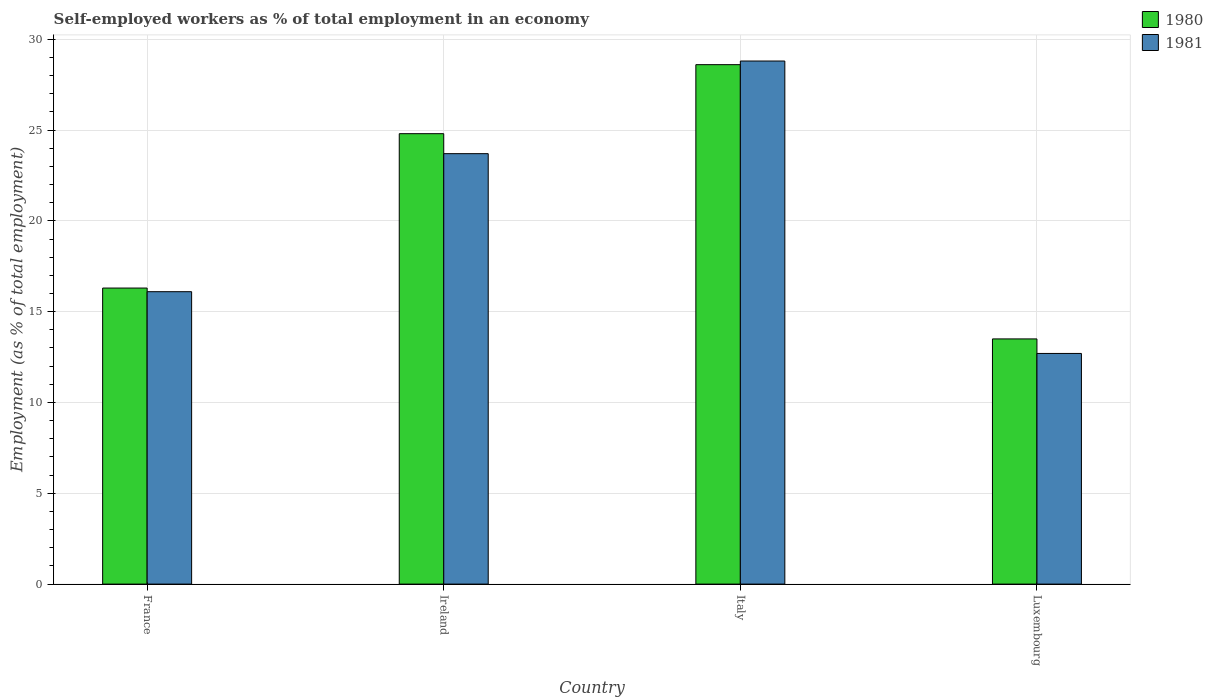How many different coloured bars are there?
Your answer should be very brief. 2. Are the number of bars on each tick of the X-axis equal?
Your answer should be compact. Yes. How many bars are there on the 3rd tick from the left?
Make the answer very short. 2. What is the label of the 3rd group of bars from the left?
Your answer should be compact. Italy. In how many cases, is the number of bars for a given country not equal to the number of legend labels?
Your response must be concise. 0. What is the percentage of self-employed workers in 1981 in France?
Keep it short and to the point. 16.1. Across all countries, what is the maximum percentage of self-employed workers in 1981?
Give a very brief answer. 28.8. In which country was the percentage of self-employed workers in 1981 maximum?
Your answer should be very brief. Italy. In which country was the percentage of self-employed workers in 1981 minimum?
Your response must be concise. Luxembourg. What is the total percentage of self-employed workers in 1980 in the graph?
Offer a terse response. 83.2. What is the difference between the percentage of self-employed workers in 1980 in France and that in Ireland?
Provide a short and direct response. -8.5. What is the difference between the percentage of self-employed workers in 1981 in Luxembourg and the percentage of self-employed workers in 1980 in France?
Ensure brevity in your answer.  -3.6. What is the average percentage of self-employed workers in 1980 per country?
Your response must be concise. 20.8. What is the difference between the percentage of self-employed workers of/in 1981 and percentage of self-employed workers of/in 1980 in Italy?
Ensure brevity in your answer.  0.2. In how many countries, is the percentage of self-employed workers in 1980 greater than 25 %?
Offer a very short reply. 1. What is the ratio of the percentage of self-employed workers in 1981 in Ireland to that in Italy?
Offer a terse response. 0.82. Is the percentage of self-employed workers in 1981 in France less than that in Italy?
Make the answer very short. Yes. What is the difference between the highest and the second highest percentage of self-employed workers in 1980?
Your answer should be compact. 8.5. What is the difference between the highest and the lowest percentage of self-employed workers in 1980?
Offer a terse response. 15.1. In how many countries, is the percentage of self-employed workers in 1980 greater than the average percentage of self-employed workers in 1980 taken over all countries?
Your answer should be very brief. 2. How many bars are there?
Provide a short and direct response. 8. How many countries are there in the graph?
Your answer should be very brief. 4. What is the difference between two consecutive major ticks on the Y-axis?
Your answer should be very brief. 5. Are the values on the major ticks of Y-axis written in scientific E-notation?
Your response must be concise. No. Does the graph contain grids?
Offer a very short reply. Yes. Where does the legend appear in the graph?
Provide a succinct answer. Top right. How many legend labels are there?
Ensure brevity in your answer.  2. How are the legend labels stacked?
Your answer should be compact. Vertical. What is the title of the graph?
Your answer should be compact. Self-employed workers as % of total employment in an economy. Does "2005" appear as one of the legend labels in the graph?
Give a very brief answer. No. What is the label or title of the X-axis?
Make the answer very short. Country. What is the label or title of the Y-axis?
Ensure brevity in your answer.  Employment (as % of total employment). What is the Employment (as % of total employment) of 1980 in France?
Keep it short and to the point. 16.3. What is the Employment (as % of total employment) of 1981 in France?
Your response must be concise. 16.1. What is the Employment (as % of total employment) in 1980 in Ireland?
Give a very brief answer. 24.8. What is the Employment (as % of total employment) of 1981 in Ireland?
Your answer should be very brief. 23.7. What is the Employment (as % of total employment) of 1980 in Italy?
Provide a short and direct response. 28.6. What is the Employment (as % of total employment) in 1981 in Italy?
Provide a short and direct response. 28.8. What is the Employment (as % of total employment) of 1981 in Luxembourg?
Your response must be concise. 12.7. Across all countries, what is the maximum Employment (as % of total employment) of 1980?
Offer a terse response. 28.6. Across all countries, what is the maximum Employment (as % of total employment) in 1981?
Your answer should be compact. 28.8. Across all countries, what is the minimum Employment (as % of total employment) of 1981?
Make the answer very short. 12.7. What is the total Employment (as % of total employment) of 1980 in the graph?
Your response must be concise. 83.2. What is the total Employment (as % of total employment) of 1981 in the graph?
Offer a very short reply. 81.3. What is the difference between the Employment (as % of total employment) of 1980 in France and that in Ireland?
Your answer should be very brief. -8.5. What is the difference between the Employment (as % of total employment) in 1981 in France and that in Ireland?
Offer a terse response. -7.6. What is the difference between the Employment (as % of total employment) in 1980 in France and that in Italy?
Your answer should be compact. -12.3. What is the difference between the Employment (as % of total employment) of 1981 in France and that in Italy?
Provide a short and direct response. -12.7. What is the difference between the Employment (as % of total employment) of 1980 in France and that in Luxembourg?
Offer a very short reply. 2.8. What is the difference between the Employment (as % of total employment) of 1981 in Ireland and that in Italy?
Your answer should be very brief. -5.1. What is the difference between the Employment (as % of total employment) in 1980 in Ireland and that in Luxembourg?
Your answer should be compact. 11.3. What is the difference between the Employment (as % of total employment) of 1980 in France and the Employment (as % of total employment) of 1981 in Ireland?
Offer a very short reply. -7.4. What is the difference between the Employment (as % of total employment) in 1980 in Ireland and the Employment (as % of total employment) in 1981 in Italy?
Ensure brevity in your answer.  -4. What is the difference between the Employment (as % of total employment) of 1980 in Italy and the Employment (as % of total employment) of 1981 in Luxembourg?
Your response must be concise. 15.9. What is the average Employment (as % of total employment) in 1980 per country?
Make the answer very short. 20.8. What is the average Employment (as % of total employment) of 1981 per country?
Make the answer very short. 20.32. What is the difference between the Employment (as % of total employment) in 1980 and Employment (as % of total employment) in 1981 in France?
Your answer should be compact. 0.2. What is the ratio of the Employment (as % of total employment) in 1980 in France to that in Ireland?
Provide a succinct answer. 0.66. What is the ratio of the Employment (as % of total employment) of 1981 in France to that in Ireland?
Ensure brevity in your answer.  0.68. What is the ratio of the Employment (as % of total employment) of 1980 in France to that in Italy?
Make the answer very short. 0.57. What is the ratio of the Employment (as % of total employment) in 1981 in France to that in Italy?
Ensure brevity in your answer.  0.56. What is the ratio of the Employment (as % of total employment) of 1980 in France to that in Luxembourg?
Offer a terse response. 1.21. What is the ratio of the Employment (as % of total employment) in 1981 in France to that in Luxembourg?
Provide a short and direct response. 1.27. What is the ratio of the Employment (as % of total employment) in 1980 in Ireland to that in Italy?
Make the answer very short. 0.87. What is the ratio of the Employment (as % of total employment) in 1981 in Ireland to that in Italy?
Provide a short and direct response. 0.82. What is the ratio of the Employment (as % of total employment) in 1980 in Ireland to that in Luxembourg?
Provide a succinct answer. 1.84. What is the ratio of the Employment (as % of total employment) of 1981 in Ireland to that in Luxembourg?
Offer a terse response. 1.87. What is the ratio of the Employment (as % of total employment) of 1980 in Italy to that in Luxembourg?
Your answer should be very brief. 2.12. What is the ratio of the Employment (as % of total employment) in 1981 in Italy to that in Luxembourg?
Provide a succinct answer. 2.27. What is the difference between the highest and the second highest Employment (as % of total employment) of 1980?
Give a very brief answer. 3.8. What is the difference between the highest and the second highest Employment (as % of total employment) in 1981?
Your answer should be very brief. 5.1. What is the difference between the highest and the lowest Employment (as % of total employment) in 1981?
Give a very brief answer. 16.1. 